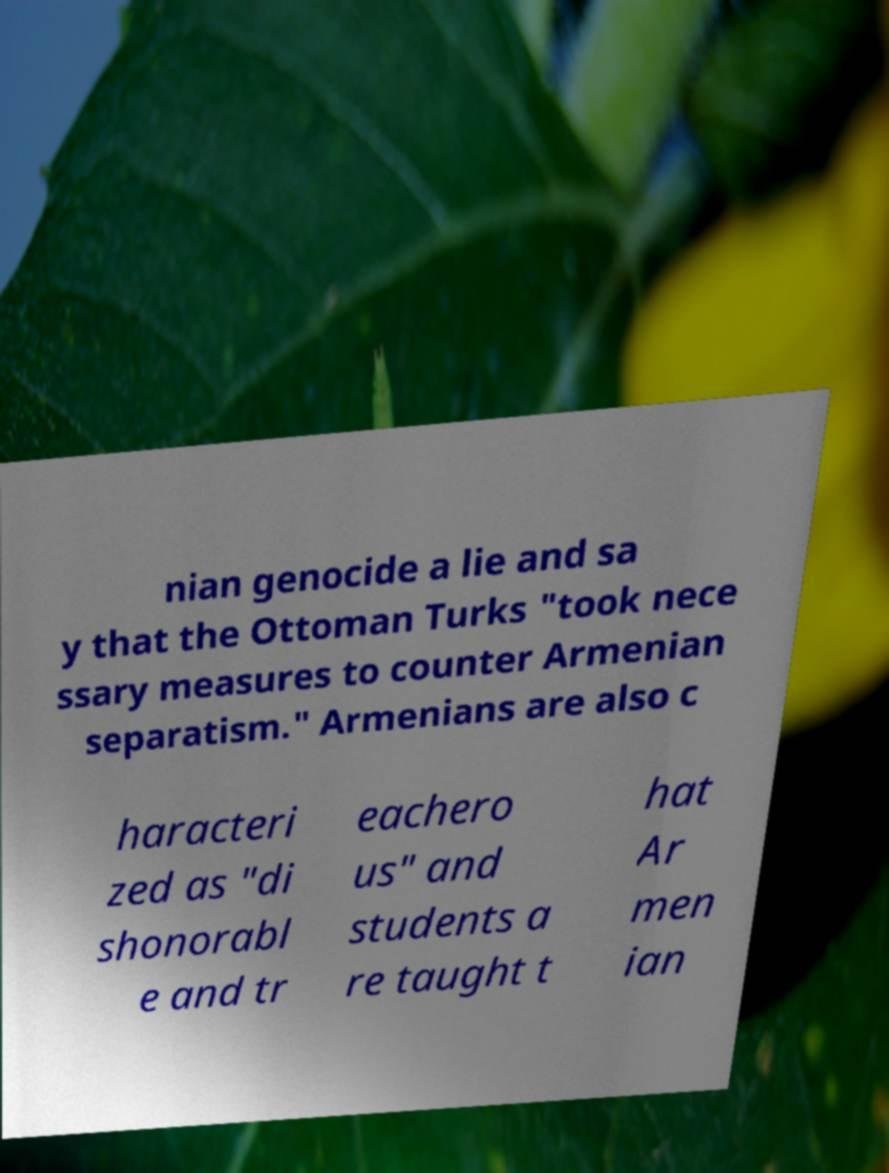Could you assist in decoding the text presented in this image and type it out clearly? nian genocide a lie and sa y that the Ottoman Turks "took nece ssary measures to counter Armenian separatism." Armenians are also c haracteri zed as "di shonorabl e and tr eachero us" and students a re taught t hat Ar men ian 